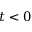<formula> <loc_0><loc_0><loc_500><loc_500>t < 0</formula> 